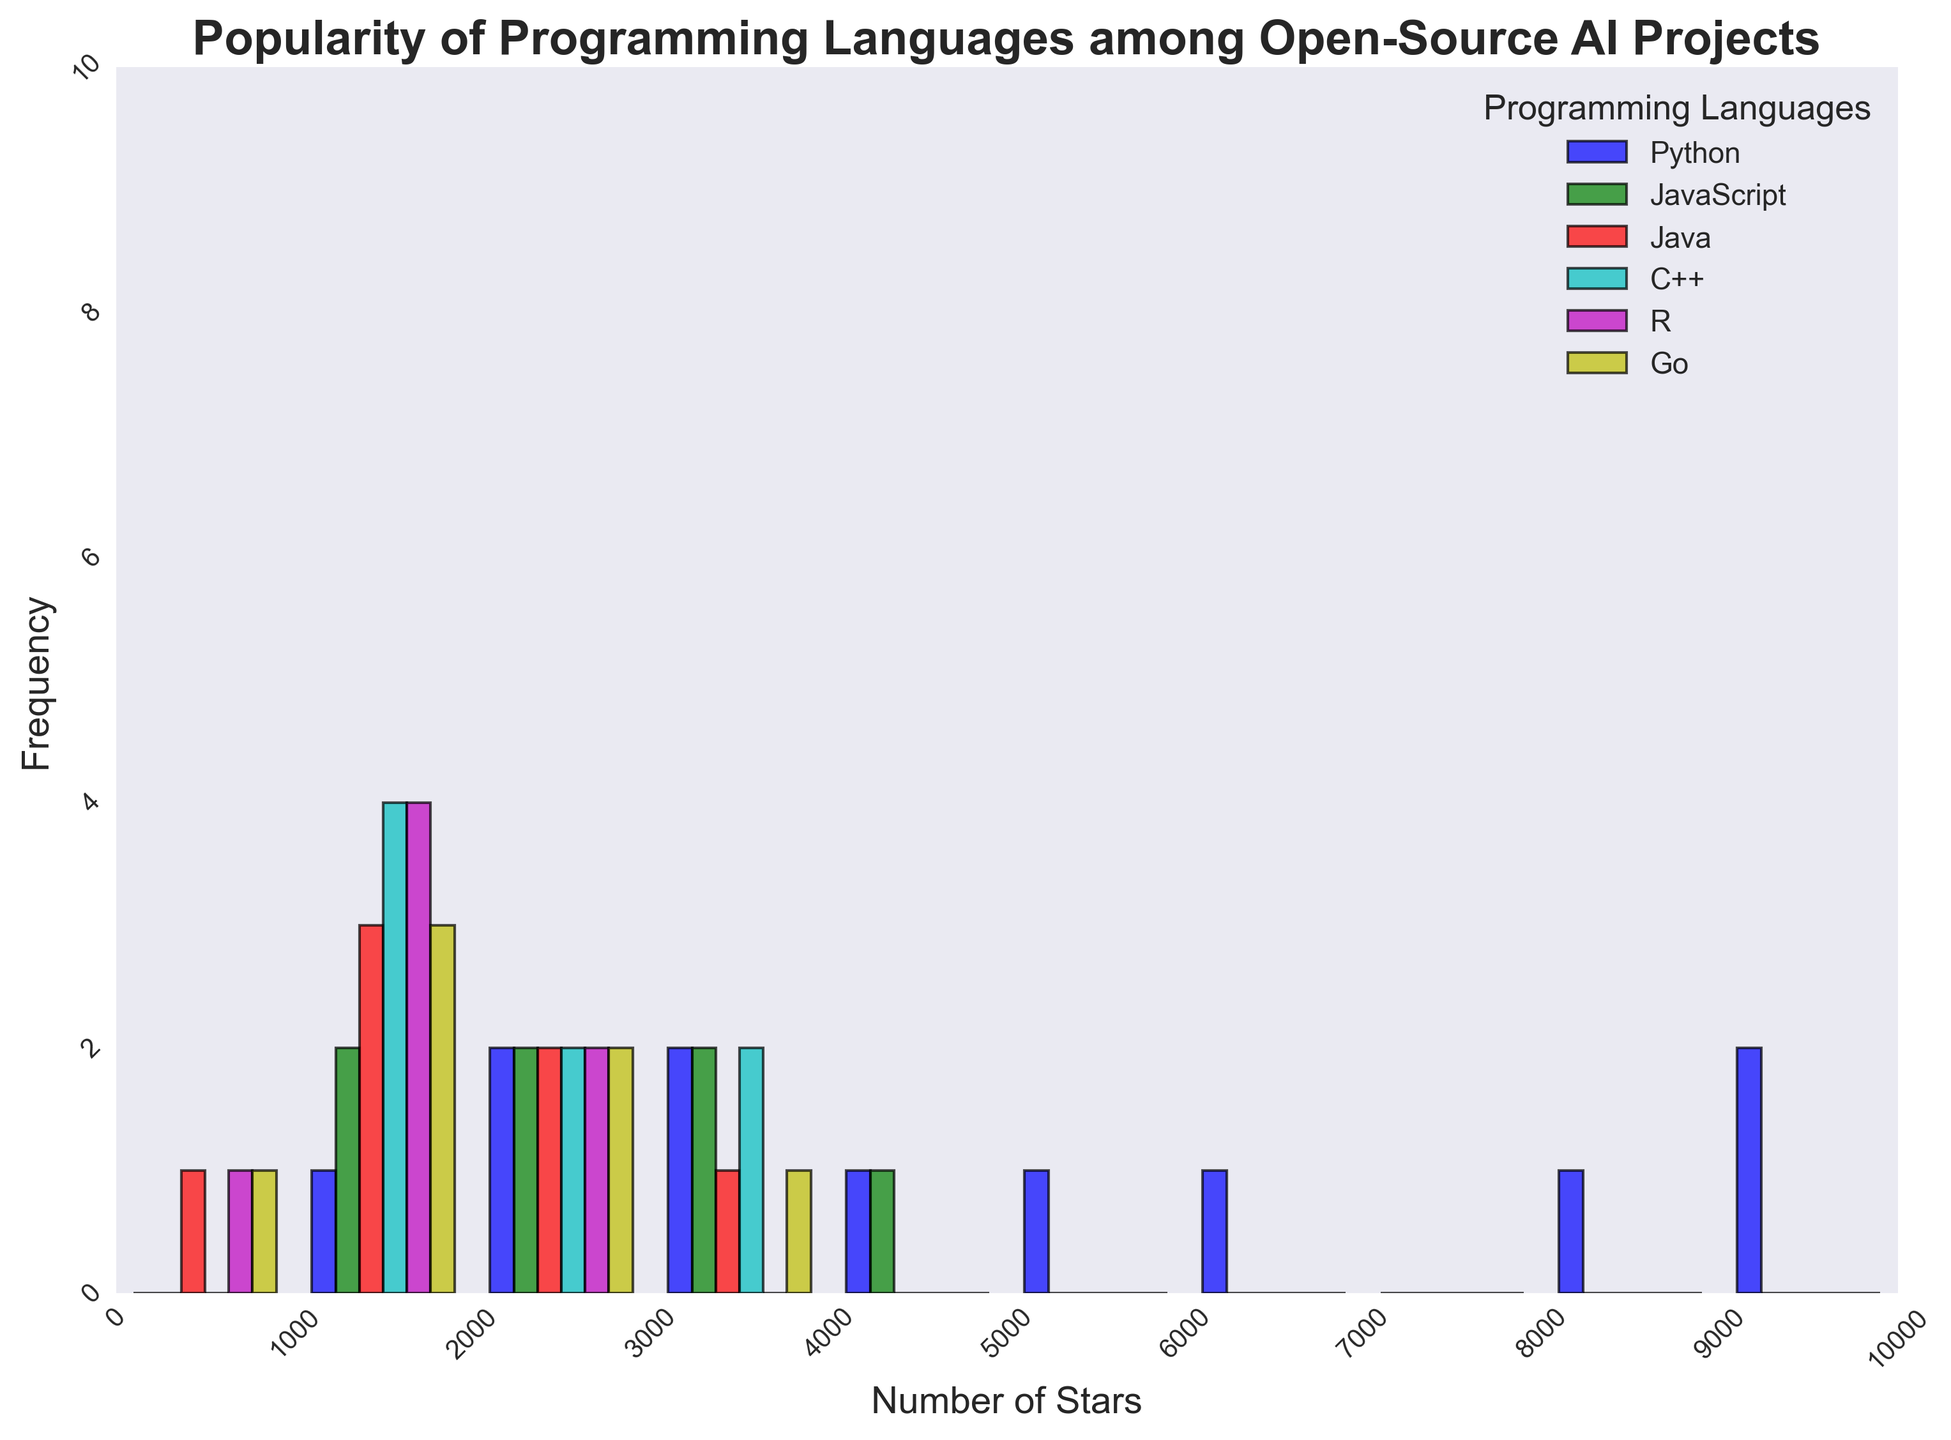What is the most frequent star range for Python projects? The histogram for Python has the tallest bar, indicating the highest frequency, in the 0-1000 star range. Hence, the most frequent star range for Python projects is between 0 and 1000 stars.
Answer: 0-1000 stars Which programming language has the highest number of projects with 3000-4000 stars? By examining the height of the bars for each programming language in the 3000-4000 star range, it is evident that Python has the highest bar, indicating the most projects within this star range.
Answer: Python How many star ranges does JavaScript cover in the histogram? JavaScript has bars in the ranges: 0-1000, 1000-2000, 2000-3000, 3000-4000. This makes 4 different ranges.
Answer: 4 Which programming language has the fewest entries in the 0-1000 star range? By comparing the height of the bars in the 0-1000 star range, the shortest one corresponds to Go.
Answer: Go What is the difference in the number of projects between Java in the 2000-3000 star range and R in the same range? Java has one bar in the 2000-3000 star range, while R also has one. Their heights show they both have relatively equal heights. This results in a difference of 0.
Answer: 0 Which programming language has the highest total number of projects displayed in the histogram? By adding the heights of all bars for each programming language, Python has the most bars with the highest overall heights combined, indicating it has the highest total number of projects.
Answer: Python Which programming language does not have any projects in the 4000-5000 star range? Observing the histogram, there are no bars for JavaScript, Java, C++, R, or Go in the 4000-5000 star range.
Answer: JavaScript, Java, C++, R, Go 